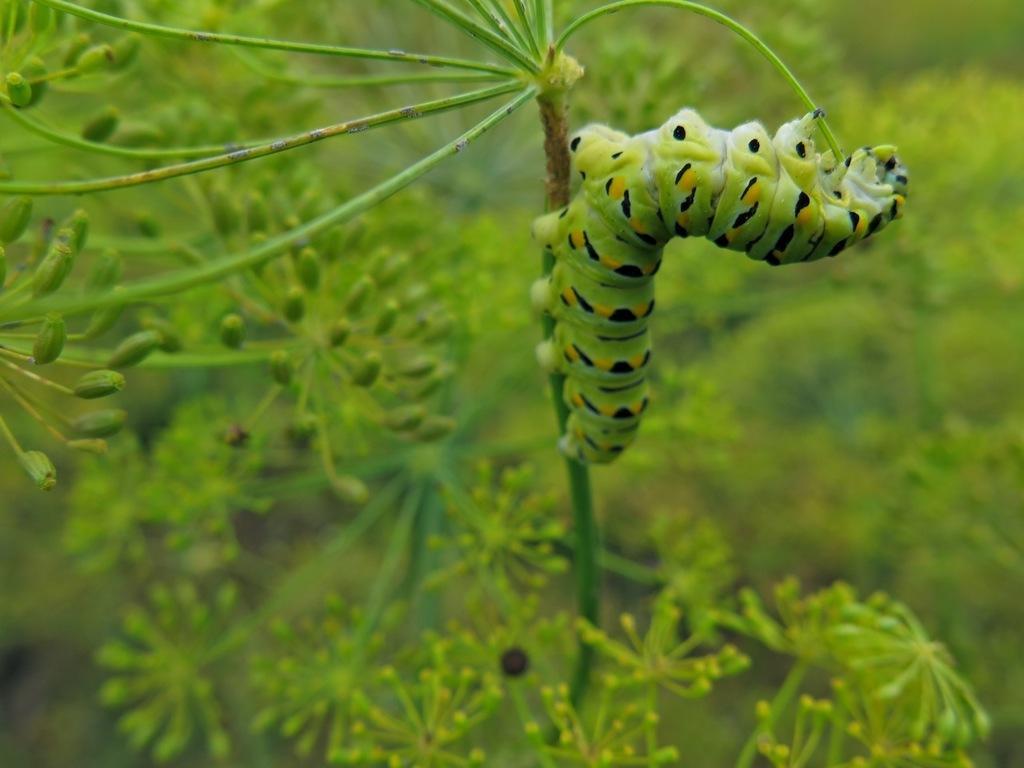How would you summarize this image in a sentence or two? In the image we can see a insect on a stem. Background of the image there are some plants. 